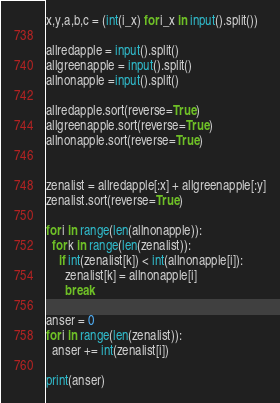<code> <loc_0><loc_0><loc_500><loc_500><_Python_>x,y,a,b,c = (int(i_x) for i_x in input().split())

allredapple = input().split()
allgreenapple = input().split()
allnonapple =input().split()

allredapple.sort(reverse=True)
allgreenapple.sort(reverse=True)
allnonapple.sort(reverse=True)


zenalist = allredapple[:x] + allgreenapple[:y]
zenalist.sort(reverse=True)

for i in range(len(allnonapple)):
  for k in range(len(zenalist)):
    if int(zenalist[k]) < int(allnonapple[i]):
      zenalist[k] = allnonapple[i]
      break

anser = 0      
for i in range(len(zenalist)):
  anser += int(zenalist[i])

print(anser)</code> 